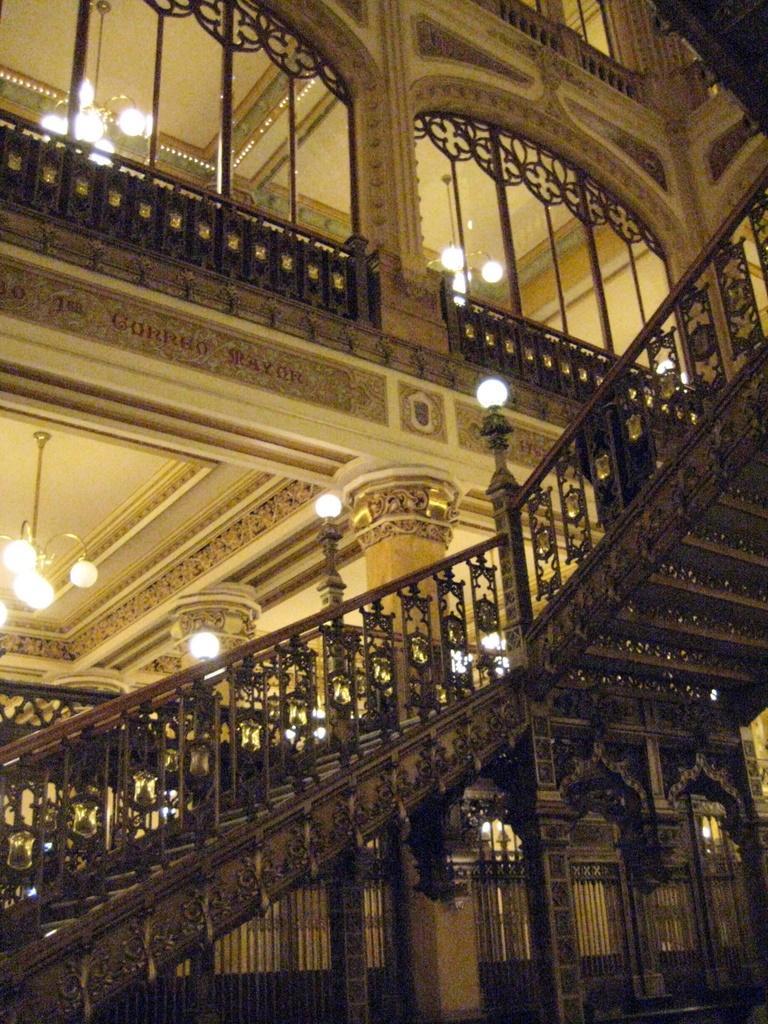Could you give a brief overview of what you see in this image? This is a picture of the inside of the building, in this picture in the center there are some stairs and in the background there are chandeliers, ceiling and pillars and in the center there is a railing. 